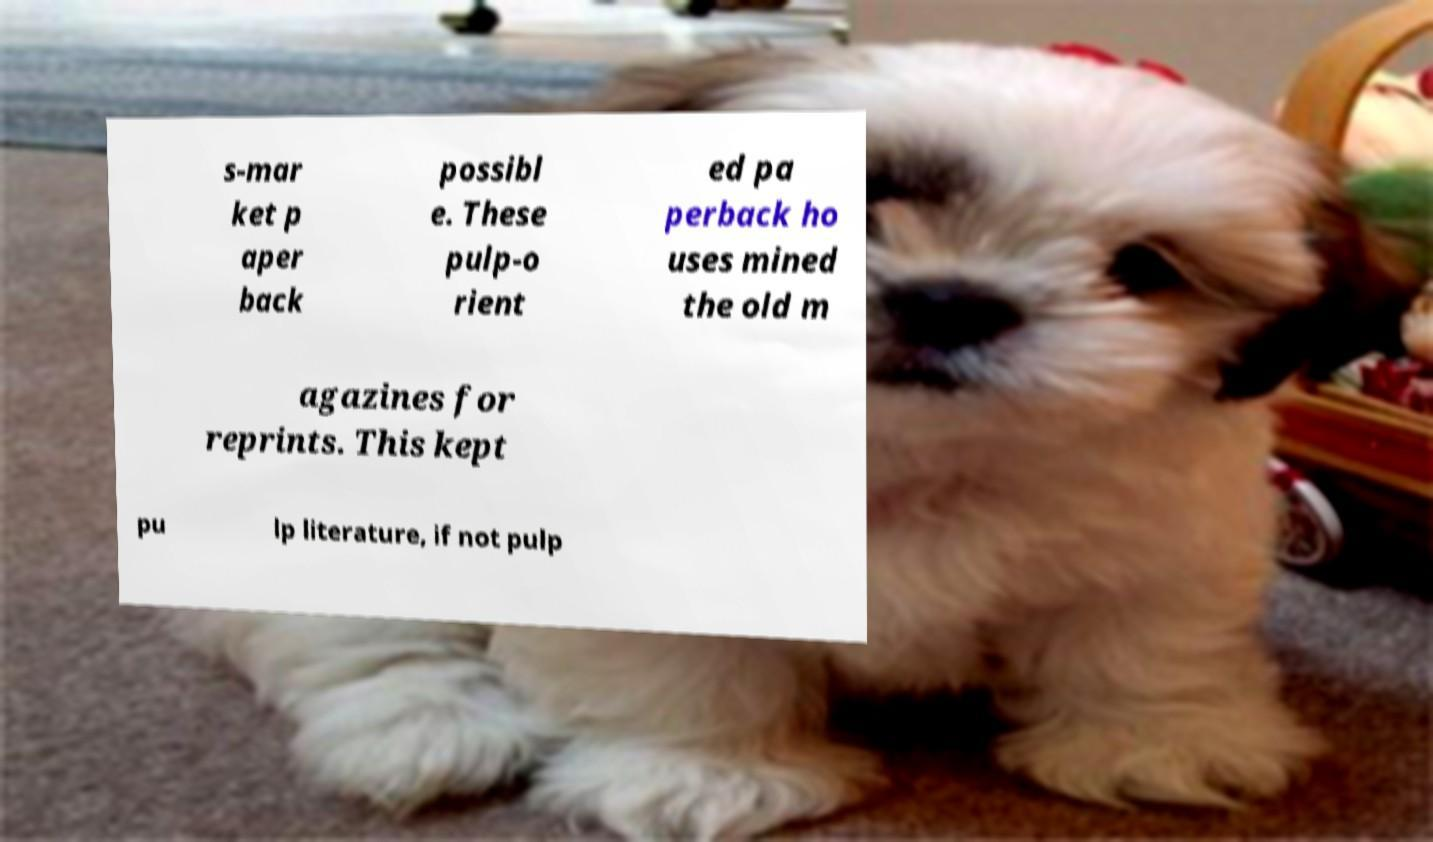Can you accurately transcribe the text from the provided image for me? s-mar ket p aper back possibl e. These pulp-o rient ed pa perback ho uses mined the old m agazines for reprints. This kept pu lp literature, if not pulp 